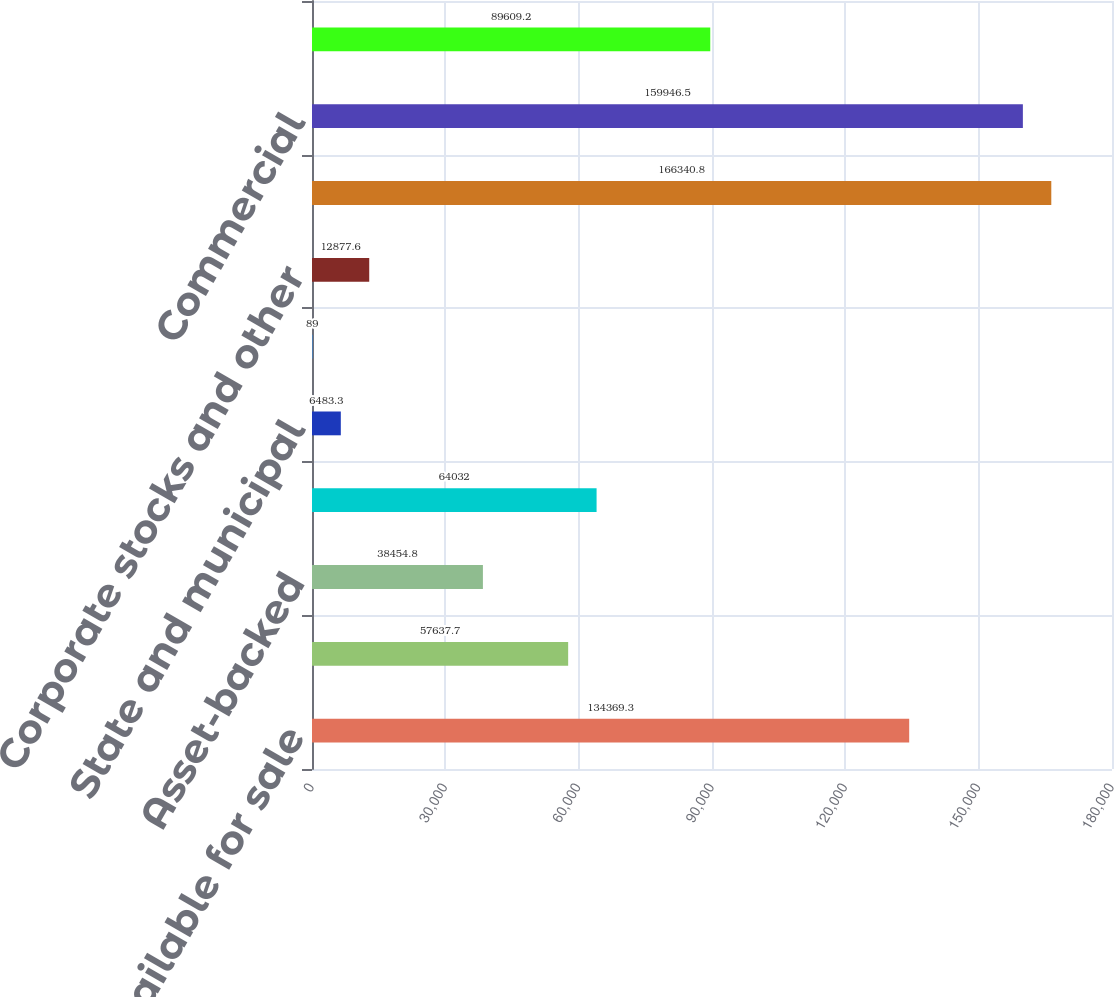Convert chart to OTSL. <chart><loc_0><loc_0><loc_500><loc_500><bar_chart><fcel>Securities available for sale<fcel>Commercial mortgage-backed<fcel>Asset-backed<fcel>US Treasury and government<fcel>State and municipal<fcel>Other debt<fcel>Corporate stocks and other<fcel>Total securities available for<fcel>Commercial<fcel>Commercial real estate<nl><fcel>134369<fcel>57637.7<fcel>38454.8<fcel>64032<fcel>6483.3<fcel>89<fcel>12877.6<fcel>166341<fcel>159946<fcel>89609.2<nl></chart> 